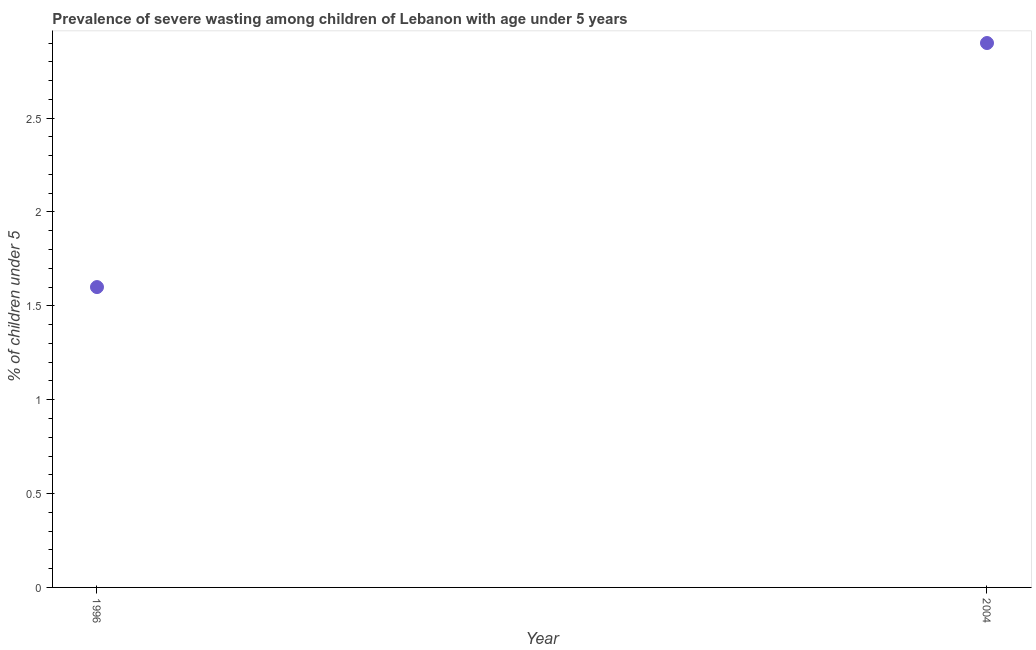What is the prevalence of severe wasting in 2004?
Your response must be concise. 2.9. Across all years, what is the maximum prevalence of severe wasting?
Offer a very short reply. 2.9. Across all years, what is the minimum prevalence of severe wasting?
Your answer should be compact. 1.6. In which year was the prevalence of severe wasting maximum?
Offer a terse response. 2004. In which year was the prevalence of severe wasting minimum?
Your answer should be compact. 1996. What is the sum of the prevalence of severe wasting?
Ensure brevity in your answer.  4.5. What is the difference between the prevalence of severe wasting in 1996 and 2004?
Provide a short and direct response. -1.3. What is the average prevalence of severe wasting per year?
Provide a short and direct response. 2.25. What is the median prevalence of severe wasting?
Offer a very short reply. 2.25. In how many years, is the prevalence of severe wasting greater than 2 %?
Your answer should be compact. 1. Do a majority of the years between 1996 and 2004 (inclusive) have prevalence of severe wasting greater than 1.3 %?
Provide a short and direct response. Yes. What is the ratio of the prevalence of severe wasting in 1996 to that in 2004?
Provide a short and direct response. 0.55. Does the prevalence of severe wasting monotonically increase over the years?
Provide a succinct answer. Yes. How many dotlines are there?
Give a very brief answer. 1. How many years are there in the graph?
Make the answer very short. 2. What is the difference between two consecutive major ticks on the Y-axis?
Keep it short and to the point. 0.5. Are the values on the major ticks of Y-axis written in scientific E-notation?
Ensure brevity in your answer.  No. Does the graph contain any zero values?
Provide a succinct answer. No. Does the graph contain grids?
Offer a very short reply. No. What is the title of the graph?
Your response must be concise. Prevalence of severe wasting among children of Lebanon with age under 5 years. What is the label or title of the Y-axis?
Offer a very short reply.  % of children under 5. What is the  % of children under 5 in 1996?
Keep it short and to the point. 1.6. What is the  % of children under 5 in 2004?
Offer a terse response. 2.9. What is the ratio of the  % of children under 5 in 1996 to that in 2004?
Provide a short and direct response. 0.55. 